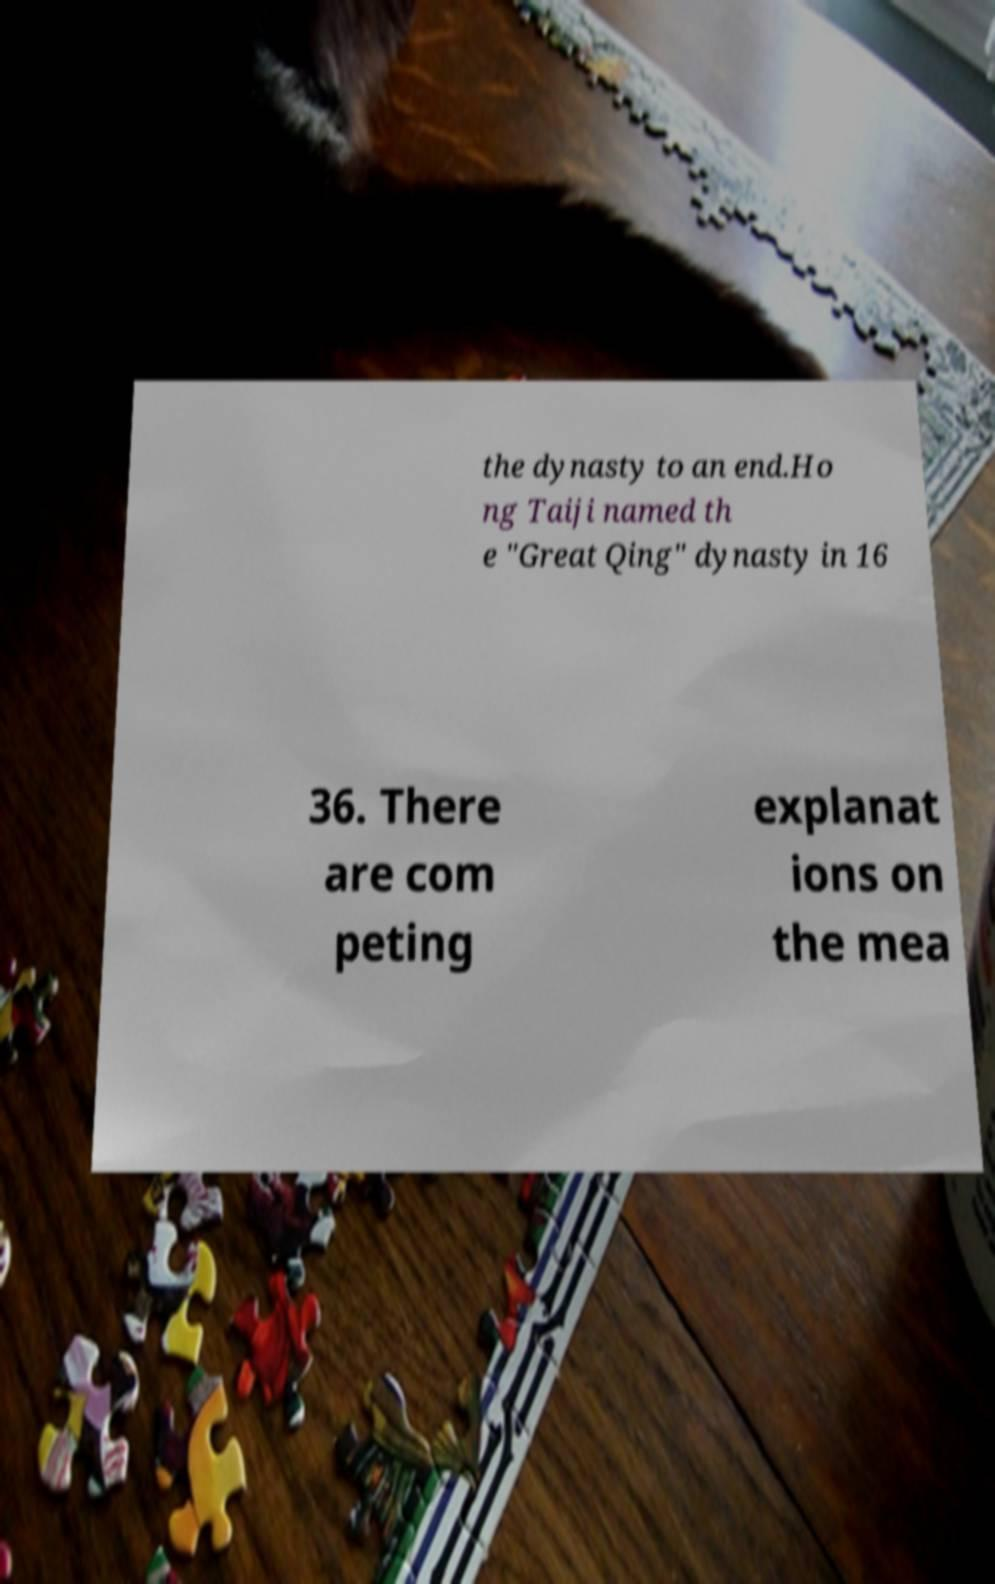There's text embedded in this image that I need extracted. Can you transcribe it verbatim? the dynasty to an end.Ho ng Taiji named th e "Great Qing" dynasty in 16 36. There are com peting explanat ions on the mea 